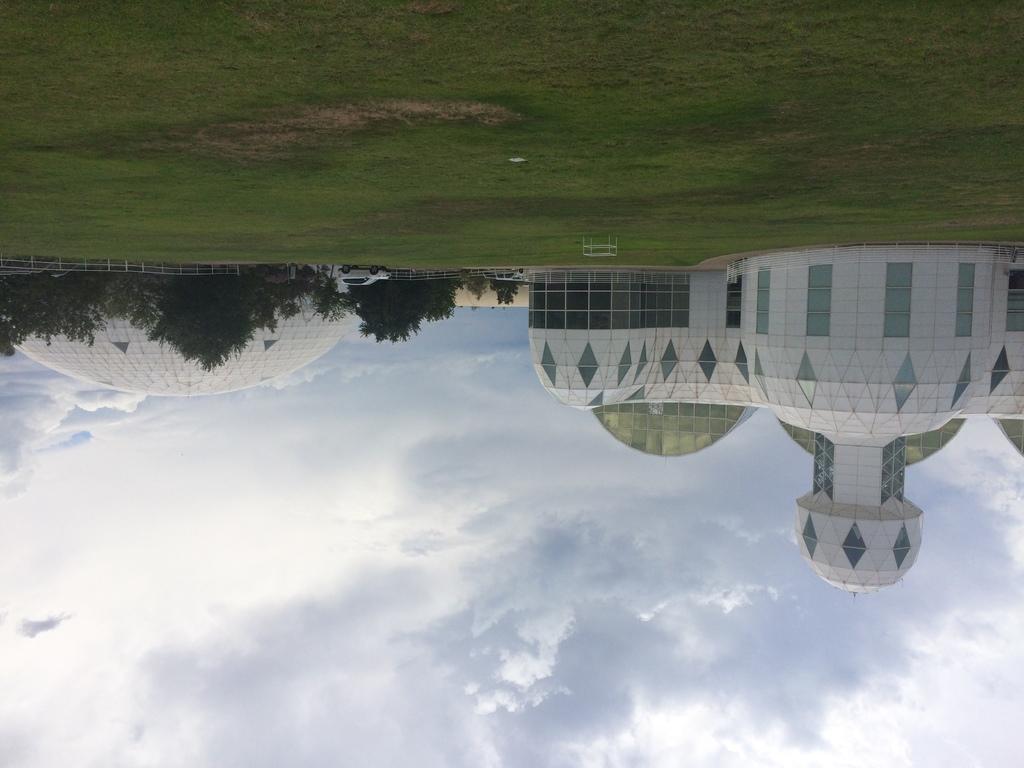Could you give a brief overview of what you see in this image? As we can see in the image there is grass, trees, buildings, sky and clouds. 